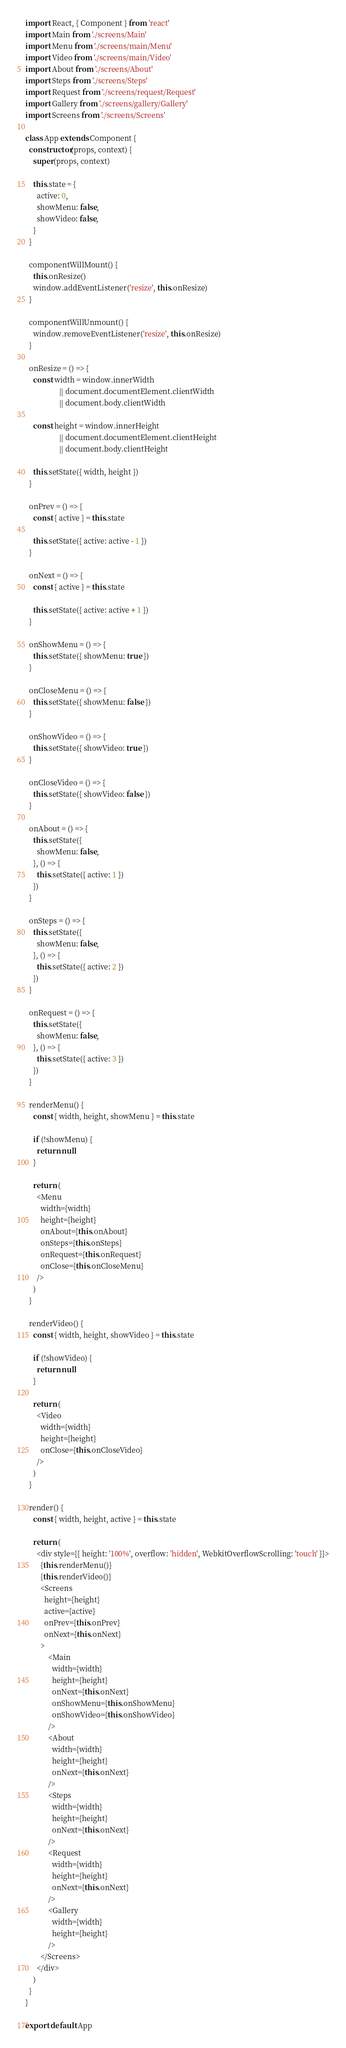Convert code to text. <code><loc_0><loc_0><loc_500><loc_500><_JavaScript_>import React, { Component } from 'react'
import Main from './screens/Main'
import Menu from './screens/main/Menu'
import Video from './screens/main/Video'
import About from './screens/About'
import Steps from './screens/Steps'
import Request from './screens/request/Request'
import Gallery from './screens/gallery/Gallery'
import Screens from './screens/Screens'

class App extends Component {
  constructor(props, context) {
    super(props, context)

    this.state = {
      active: 0,
      showMenu: false,
      showVideo: false,
    }
  }

  componentWillMount() {
    this.onResize()
    window.addEventListener('resize', this.onResize)
  }

  componentWillUnmount() {
    window.removeEventListener('resize', this.onResize)
  }

  onResize = () => {
    const width = window.innerWidth
                  || document.documentElement.clientWidth
                  || document.body.clientWidth

    const height = window.innerHeight
                  || document.documentElement.clientHeight
                  || document.body.clientHeight

    this.setState({ width, height })
  }

  onPrev = () => {
    const { active } = this.state

    this.setState({ active: active - 1 })
  }

  onNext = () => {
    const { active } = this.state

    this.setState({ active: active + 1 })
  }

  onShowMenu = () => {
    this.setState({ showMenu: true })
  }

  onCloseMenu = () => {
    this.setState({ showMenu: false })
  }

  onShowVideo = () => {
    this.setState({ showVideo: true })
  }

  onCloseVideo = () => {
    this.setState({ showVideo: false })
  }

  onAbout = () => {
    this.setState({
      showMenu: false,
    }, () => {
      this.setState({ active: 1 })
    })
  }

  onSteps = () => {
    this.setState({
      showMenu: false,
    }, () => {
      this.setState({ active: 2 })
    })
  }

  onRequest = () => {
    this.setState({
      showMenu: false,
    }, () => {
      this.setState({ active: 3 })
    })
  }

  renderMenu() {
    const { width, height, showMenu } = this.state

    if (!showMenu) {
      return null
    }

    return (
      <Menu
        width={width}
        height={height}
        onAbout={this.onAbout}
        onSteps={this.onSteps}
        onRequest={this.onRequest}
        onClose={this.onCloseMenu}
      />
    )
  }

  renderVideo() {
    const { width, height, showVideo } = this.state

    if (!showVideo) {
      return null
    }

    return (
      <Video
        width={width}
        height={height}
        onClose={this.onCloseVideo}
      />
    )
  }

  render() {
    const { width, height, active } = this.state

    return (
      <div style={{ height: '100%', overflow: 'hidden', WebkitOverflowScrolling: 'touch' }}>
        {this.renderMenu()}
        {this.renderVideo()}
        <Screens
          height={height}
          active={active}
          onPrev={this.onPrev}
          onNext={this.onNext}
        >
            <Main
              width={width}
              height={height}
              onNext={this.onNext}
              onShowMenu={this.onShowMenu}
              onShowVideo={this.onShowVideo}
            />
            <About
              width={width}
              height={height}
              onNext={this.onNext}
            />
            <Steps
              width={width}
              height={height}
              onNext={this.onNext}
            />
            <Request
              width={width}
              height={height}
              onNext={this.onNext}
            />
            <Gallery
              width={width}
              height={height}
            />
        </Screens>
      </div>
    )
  }
}

export default App
</code> 